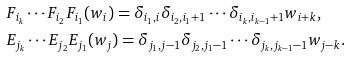Convert formula to latex. <formula><loc_0><loc_0><loc_500><loc_500>& F _ { i _ { k } } \cdots F _ { i _ { 2 } } F _ { i _ { 1 } } ( w _ { i } ) = \delta _ { i _ { 1 } , i } \delta _ { i _ { 2 } , i _ { 1 } + 1 } \cdots \delta _ { i _ { k } , i _ { k - 1 } + 1 } w _ { i + k } , \\ & E _ { j _ { k } } \cdots E _ { j _ { 2 } } E _ { j _ { 1 } } ( w _ { j } ) = \delta _ { j _ { 1 } , j - 1 } \delta _ { j _ { 2 } , j _ { 1 } - 1 } \cdots \delta _ { j _ { k } , j _ { k - 1 } - 1 } w _ { j - k } .</formula> 